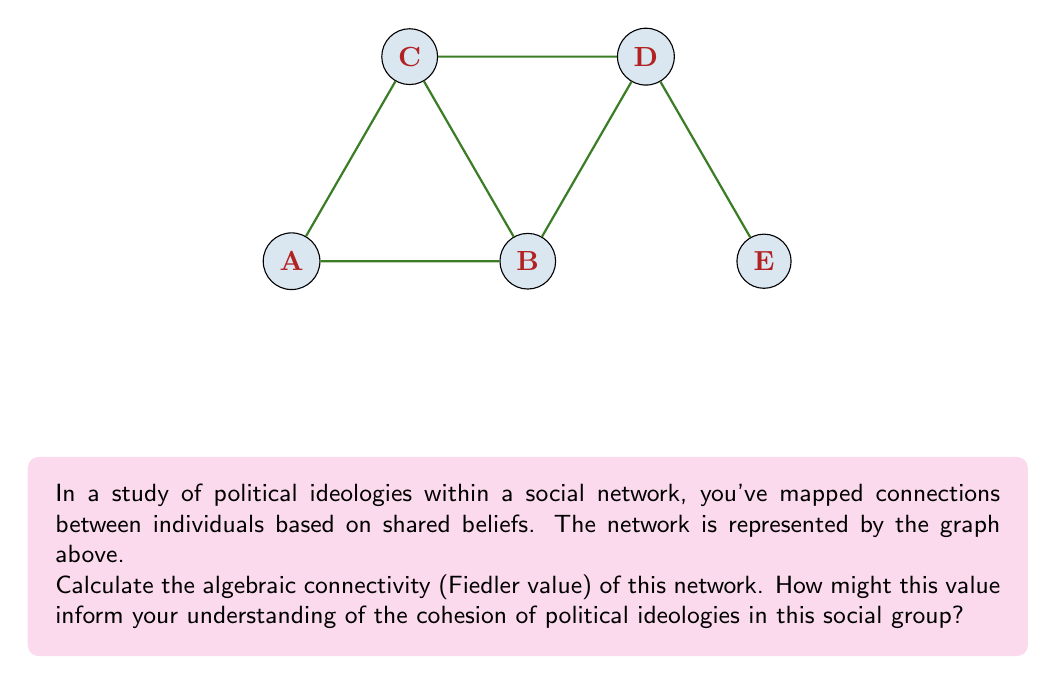Teach me how to tackle this problem. To solve this problem, we'll follow these steps:

1) First, we need to construct the Laplacian matrix $L$ of the graph. The Laplacian matrix is defined as $L = D - A$, where $D$ is the degree matrix and $A$ is the adjacency matrix.

2) The adjacency matrix $A$ for this graph is:

   $$A = \begin{bmatrix}
   0 & 1 & 1 & 0 & 0 \\
   1 & 0 & 1 & 1 & 0 \\
   1 & 1 & 0 & 1 & 0 \\
   0 & 1 & 1 & 0 & 1 \\
   0 & 0 & 0 & 1 & 0
   \end{bmatrix}$$

3) The degree matrix $D$ is:

   $$D = \begin{bmatrix}
   2 & 0 & 0 & 0 & 0 \\
   0 & 3 & 0 & 0 & 0 \\
   0 & 0 & 3 & 0 & 0 \\
   0 & 0 & 0 & 3 & 0 \\
   0 & 0 & 0 & 0 & 1
   \end{bmatrix}$$

4) The Laplacian matrix $L = D - A$ is:

   $$L = \begin{bmatrix}
   2 & -1 & -1 & 0 & 0 \\
   -1 & 3 & -1 & -1 & 0 \\
   -1 & -1 & 3 & -1 & 0 \\
   0 & -1 & -1 & 3 & -1 \\
   0 & 0 & 0 & -1 & 1
   \end{bmatrix}$$

5) The algebraic connectivity (Fiedler value) is the second smallest eigenvalue of $L$.

6) Calculating the eigenvalues of $L$, we get:
   $\lambda_1 = 0$
   $\lambda_2 \approx 0.5188$
   $\lambda_3 \approx 2.0000$
   $\lambda_4 \approx 3.3812$
   $\lambda_5 \approx 4.1000$

7) The Fiedler value is $\lambda_2 \approx 0.5188$.

This value provides insight into the cohesion of political ideologies in the social group. A higher Fiedler value indicates better connectivity and more cohesion. The value of 0.5188 suggests moderate connectivity, implying that while there are shared beliefs, there's also some ideological diversity or potential for division within the network.
Answer: $0.5188$ 